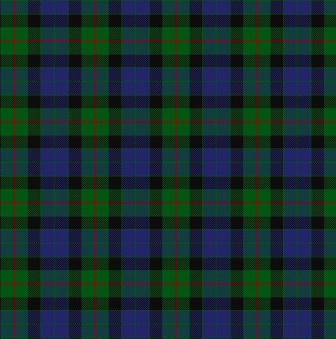What is this photo about? This image depicts a digitally rendered tartan plaid design. The pattern consists of a grid of squares and rectangles in green, blue, black, and red, which repeat both horizontally and vertically. These shapes intersect and overlap to create a layered effect, characteristic of traditional tartan patterns often used in fabrics and textiles. The precision of the digital format gives the design sharp lines and distinct colors with a clean look. The image is static and two-dimensional with no text, objects, or figures present. 